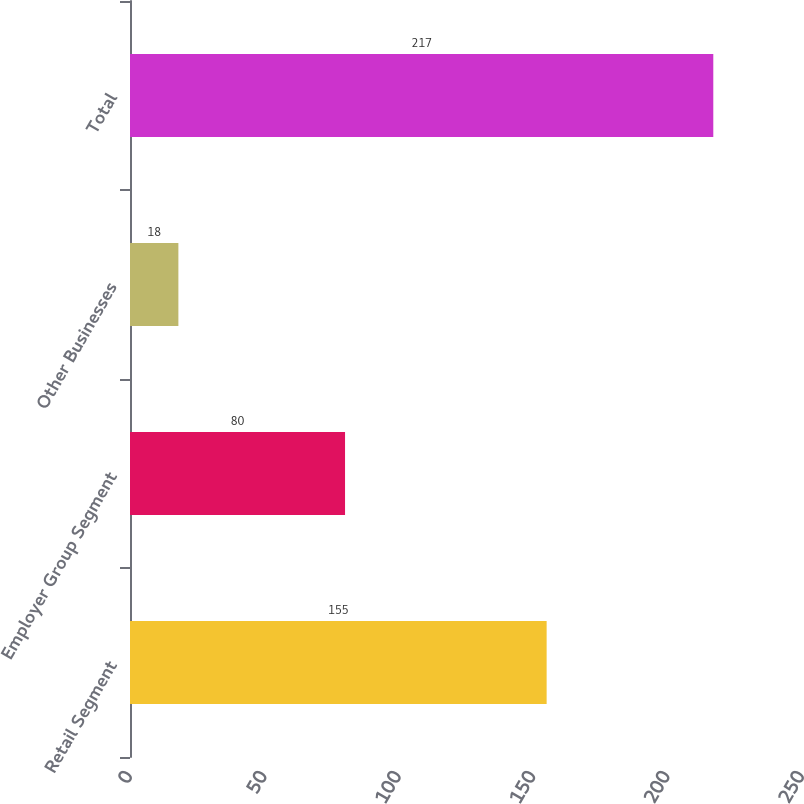Convert chart to OTSL. <chart><loc_0><loc_0><loc_500><loc_500><bar_chart><fcel>Retail Segment<fcel>Employer Group Segment<fcel>Other Businesses<fcel>Total<nl><fcel>155<fcel>80<fcel>18<fcel>217<nl></chart> 